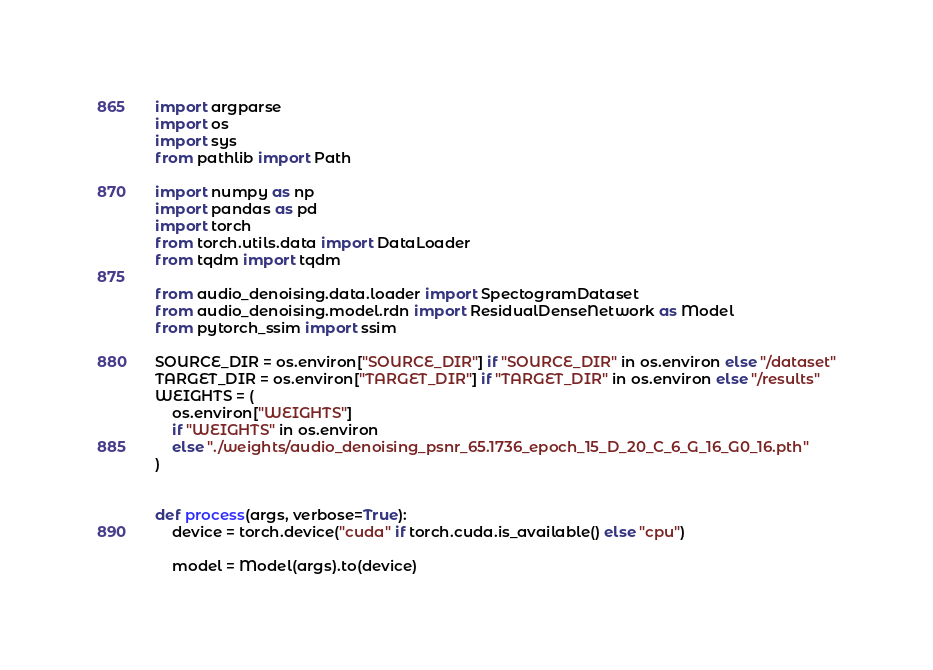<code> <loc_0><loc_0><loc_500><loc_500><_Python_>import argparse
import os
import sys
from pathlib import Path

import numpy as np
import pandas as pd
import torch
from torch.utils.data import DataLoader
from tqdm import tqdm

from audio_denoising.data.loader import SpectogramDataset
from audio_denoising.model.rdn import ResidualDenseNetwork as Model
from pytorch_ssim import ssim

SOURCE_DIR = os.environ["SOURCE_DIR"] if "SOURCE_DIR" in os.environ else "/dataset"
TARGET_DIR = os.environ["TARGET_DIR"] if "TARGET_DIR" in os.environ else "/results"
WEIGHTS = (
    os.environ["WEIGHTS"]
    if "WEIGHTS" in os.environ
    else "./weights/audio_denoising_psnr_65.1736_epoch_15_D_20_C_6_G_16_G0_16.pth"
)


def process(args, verbose=True):
    device = torch.device("cuda" if torch.cuda.is_available() else "cpu")

    model = Model(args).to(device)</code> 